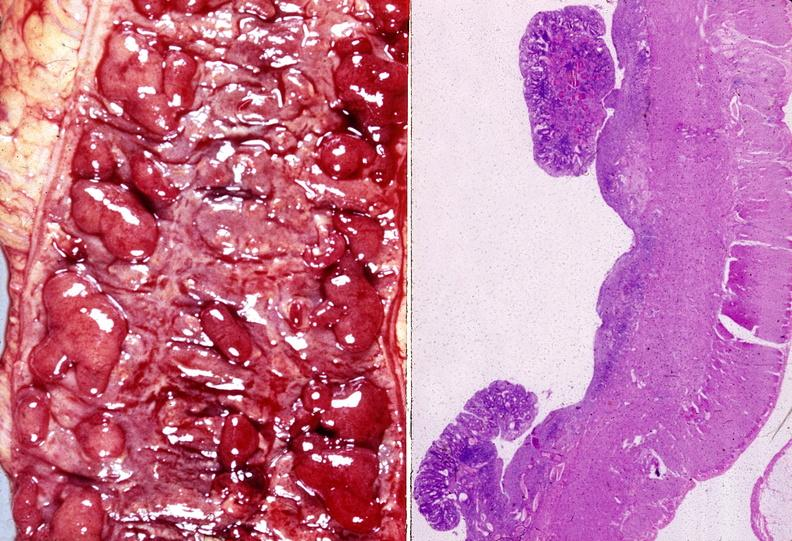s gastrointestinal present?
Answer the question using a single word or phrase. Yes 